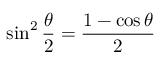Convert formula to latex. <formula><loc_0><loc_0><loc_500><loc_500>\sin ^ { 2 } { \frac { \theta } { 2 } } = { \frac { 1 - \cos \theta } { 2 } }</formula> 